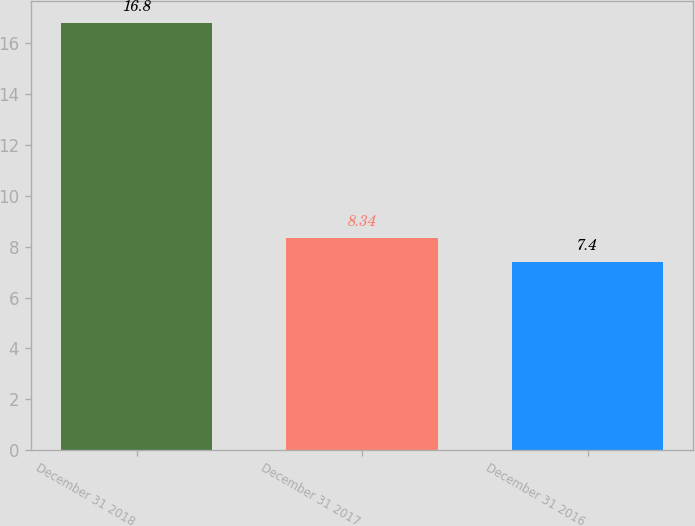Convert chart to OTSL. <chart><loc_0><loc_0><loc_500><loc_500><bar_chart><fcel>December 31 2018<fcel>December 31 2017<fcel>December 31 2016<nl><fcel>16.8<fcel>8.34<fcel>7.4<nl></chart> 